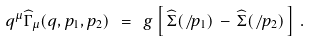Convert formula to latex. <formula><loc_0><loc_0><loc_500><loc_500>q ^ { \mu } \widehat { \Gamma } _ { \mu } ( q , p _ { 1 } , p _ { 2 } ) \ = \ g \left [ \, \widehat { \Sigma } ( \not \, p _ { 1 } ) \, - \, \widehat { \Sigma } ( \not \, p _ { 2 } ) \, \right ] \, .</formula> 